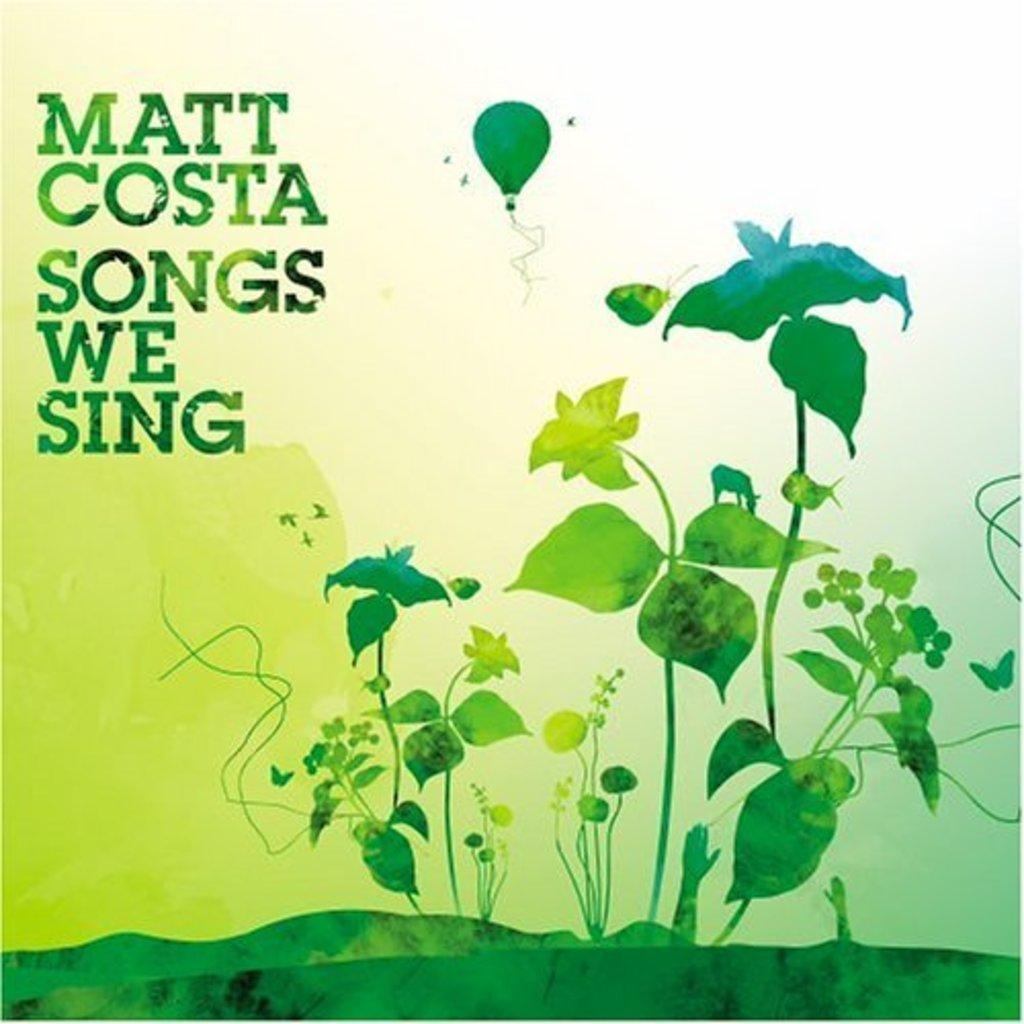What is the main subject of the poster in the image? The poster contains images of plants, an image of paragliding, and an image of grass. Are there any other elements on the poster besides the images? Yes, there is text on the poster. What is the title of the religious book depicted in the image? There is no religious book or title present in the image; the poster contains images of plants, paragliding, and grass, along with text. How many crows can be seen on the poster? There are no crows present in the image. 